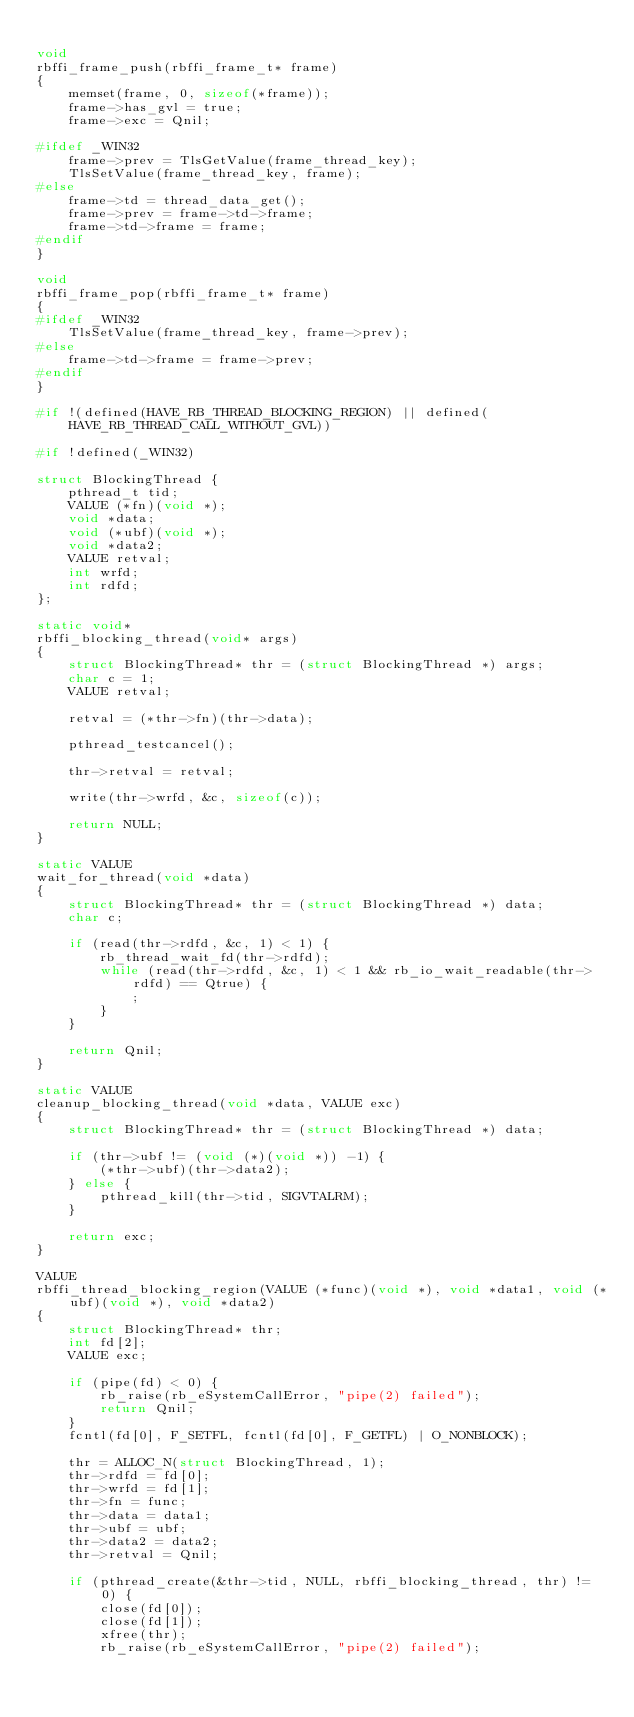<code> <loc_0><loc_0><loc_500><loc_500><_C_>
void 
rbffi_frame_push(rbffi_frame_t* frame)
{
    memset(frame, 0, sizeof(*frame));
    frame->has_gvl = true;
    frame->exc = Qnil;
    
#ifdef _WIN32
    frame->prev = TlsGetValue(frame_thread_key);
    TlsSetValue(frame_thread_key, frame);
#else
    frame->td = thread_data_get();
    frame->prev = frame->td->frame;
    frame->td->frame = frame;
#endif
}

void 
rbffi_frame_pop(rbffi_frame_t* frame)
{
#ifdef _WIN32
    TlsSetValue(frame_thread_key, frame->prev);
#else
    frame->td->frame = frame->prev;
#endif
}

#if !(defined(HAVE_RB_THREAD_BLOCKING_REGION) || defined(HAVE_RB_THREAD_CALL_WITHOUT_GVL))

#if !defined(_WIN32)

struct BlockingThread {
    pthread_t tid;
    VALUE (*fn)(void *);
    void *data;
    void (*ubf)(void *);
    void *data2;
    VALUE retval;
    int wrfd;
    int rdfd;
};

static void*
rbffi_blocking_thread(void* args)
{
    struct BlockingThread* thr = (struct BlockingThread *) args;
    char c = 1;
    VALUE retval;
    
    retval = (*thr->fn)(thr->data);
    
    pthread_testcancel();

    thr->retval = retval;
    
    write(thr->wrfd, &c, sizeof(c));

    return NULL;
}

static VALUE
wait_for_thread(void *data)
{
    struct BlockingThread* thr = (struct BlockingThread *) data;
    char c;
    
    if (read(thr->rdfd, &c, 1) < 1) {
        rb_thread_wait_fd(thr->rdfd);
        while (read(thr->rdfd, &c, 1) < 1 && rb_io_wait_readable(thr->rdfd) == Qtrue) {
            ;
        }
    }

    return Qnil;
}

static VALUE
cleanup_blocking_thread(void *data, VALUE exc)
{
    struct BlockingThread* thr = (struct BlockingThread *) data;

    if (thr->ubf != (void (*)(void *)) -1) {
        (*thr->ubf)(thr->data2);
    } else {
        pthread_kill(thr->tid, SIGVTALRM);
    }

    return exc;
}

VALUE
rbffi_thread_blocking_region(VALUE (*func)(void *), void *data1, void (*ubf)(void *), void *data2)
{
    struct BlockingThread* thr;
    int fd[2];
    VALUE exc;
    
    if (pipe(fd) < 0) {
        rb_raise(rb_eSystemCallError, "pipe(2) failed");
        return Qnil;
    }
    fcntl(fd[0], F_SETFL, fcntl(fd[0], F_GETFL) | O_NONBLOCK);

    thr = ALLOC_N(struct BlockingThread, 1);
    thr->rdfd = fd[0];
    thr->wrfd = fd[1];
    thr->fn = func;
    thr->data = data1;
    thr->ubf = ubf;
    thr->data2 = data2;
    thr->retval = Qnil;

    if (pthread_create(&thr->tid, NULL, rbffi_blocking_thread, thr) != 0) {
        close(fd[0]);
        close(fd[1]);
        xfree(thr);
        rb_raise(rb_eSystemCallError, "pipe(2) failed");</code> 